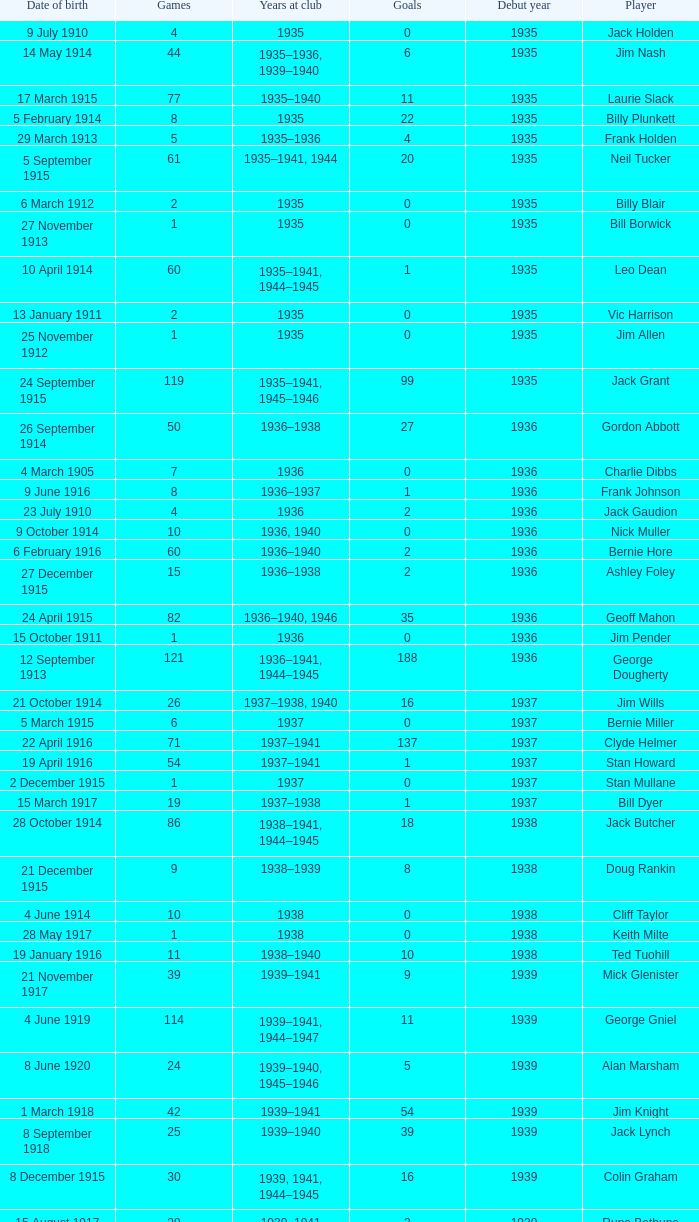What is the average games a player born on 17 March 1915 and debut before 1935 had? None. 